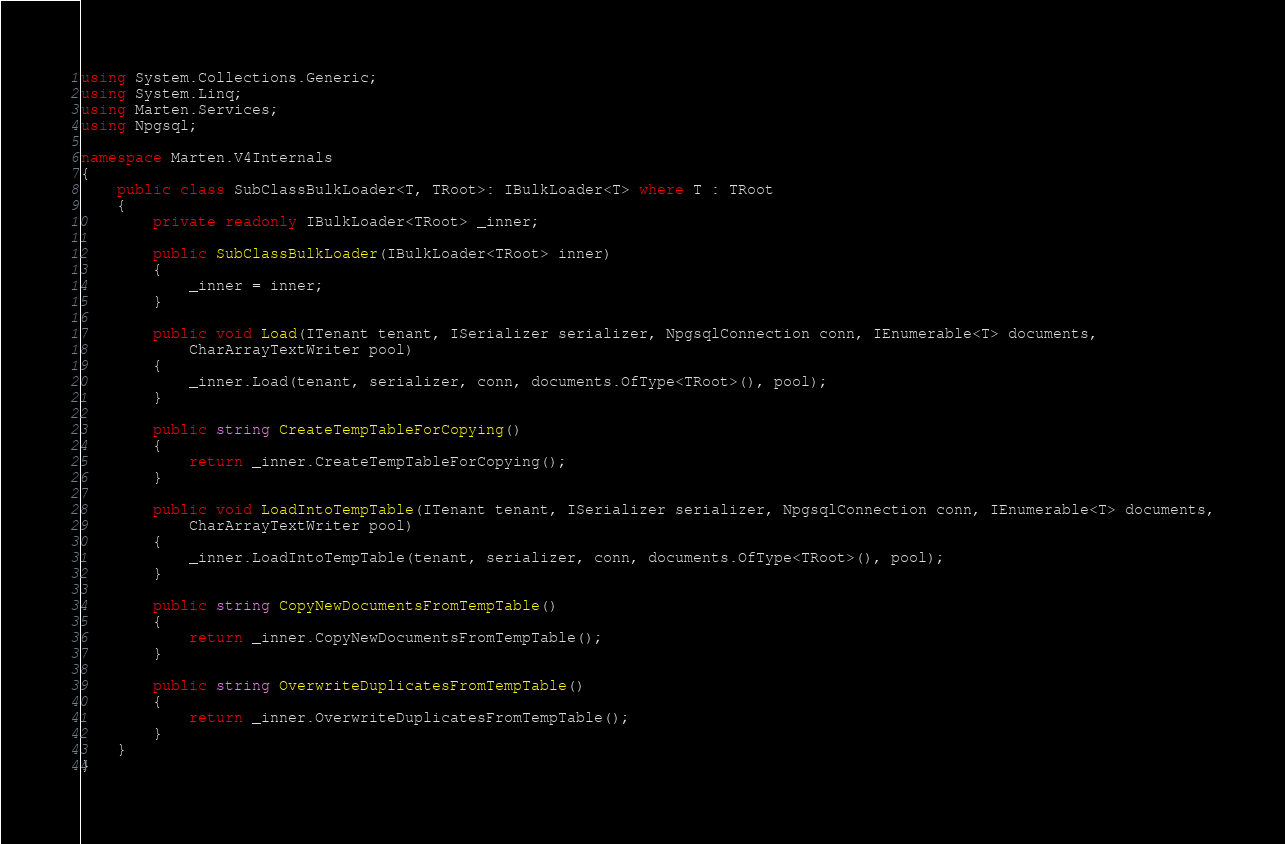<code> <loc_0><loc_0><loc_500><loc_500><_C#_>using System.Collections.Generic;
using System.Linq;
using Marten.Services;
using Npgsql;

namespace Marten.V4Internals
{
    public class SubClassBulkLoader<T, TRoot>: IBulkLoader<T> where T : TRoot
    {
        private readonly IBulkLoader<TRoot> _inner;

        public SubClassBulkLoader(IBulkLoader<TRoot> inner)
        {
            _inner = inner;
        }

        public void Load(ITenant tenant, ISerializer serializer, NpgsqlConnection conn, IEnumerable<T> documents,
            CharArrayTextWriter pool)
        {
            _inner.Load(tenant, serializer, conn, documents.OfType<TRoot>(), pool);
        }

        public string CreateTempTableForCopying()
        {
            return _inner.CreateTempTableForCopying();
        }

        public void LoadIntoTempTable(ITenant tenant, ISerializer serializer, NpgsqlConnection conn, IEnumerable<T> documents,
            CharArrayTextWriter pool)
        {
            _inner.LoadIntoTempTable(tenant, serializer, conn, documents.OfType<TRoot>(), pool);
        }

        public string CopyNewDocumentsFromTempTable()
        {
            return _inner.CopyNewDocumentsFromTempTable();
        }

        public string OverwriteDuplicatesFromTempTable()
        {
            return _inner.OverwriteDuplicatesFromTempTable();
        }
    }
}
</code> 